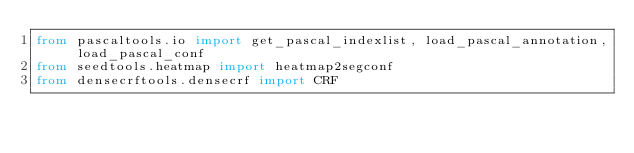Convert code to text. <code><loc_0><loc_0><loc_500><loc_500><_Python_>from pascaltools.io import get_pascal_indexlist, load_pascal_annotation, load_pascal_conf
from seedtools.heatmap import heatmap2segconf
from densecrftools.densecrf import CRF
</code> 